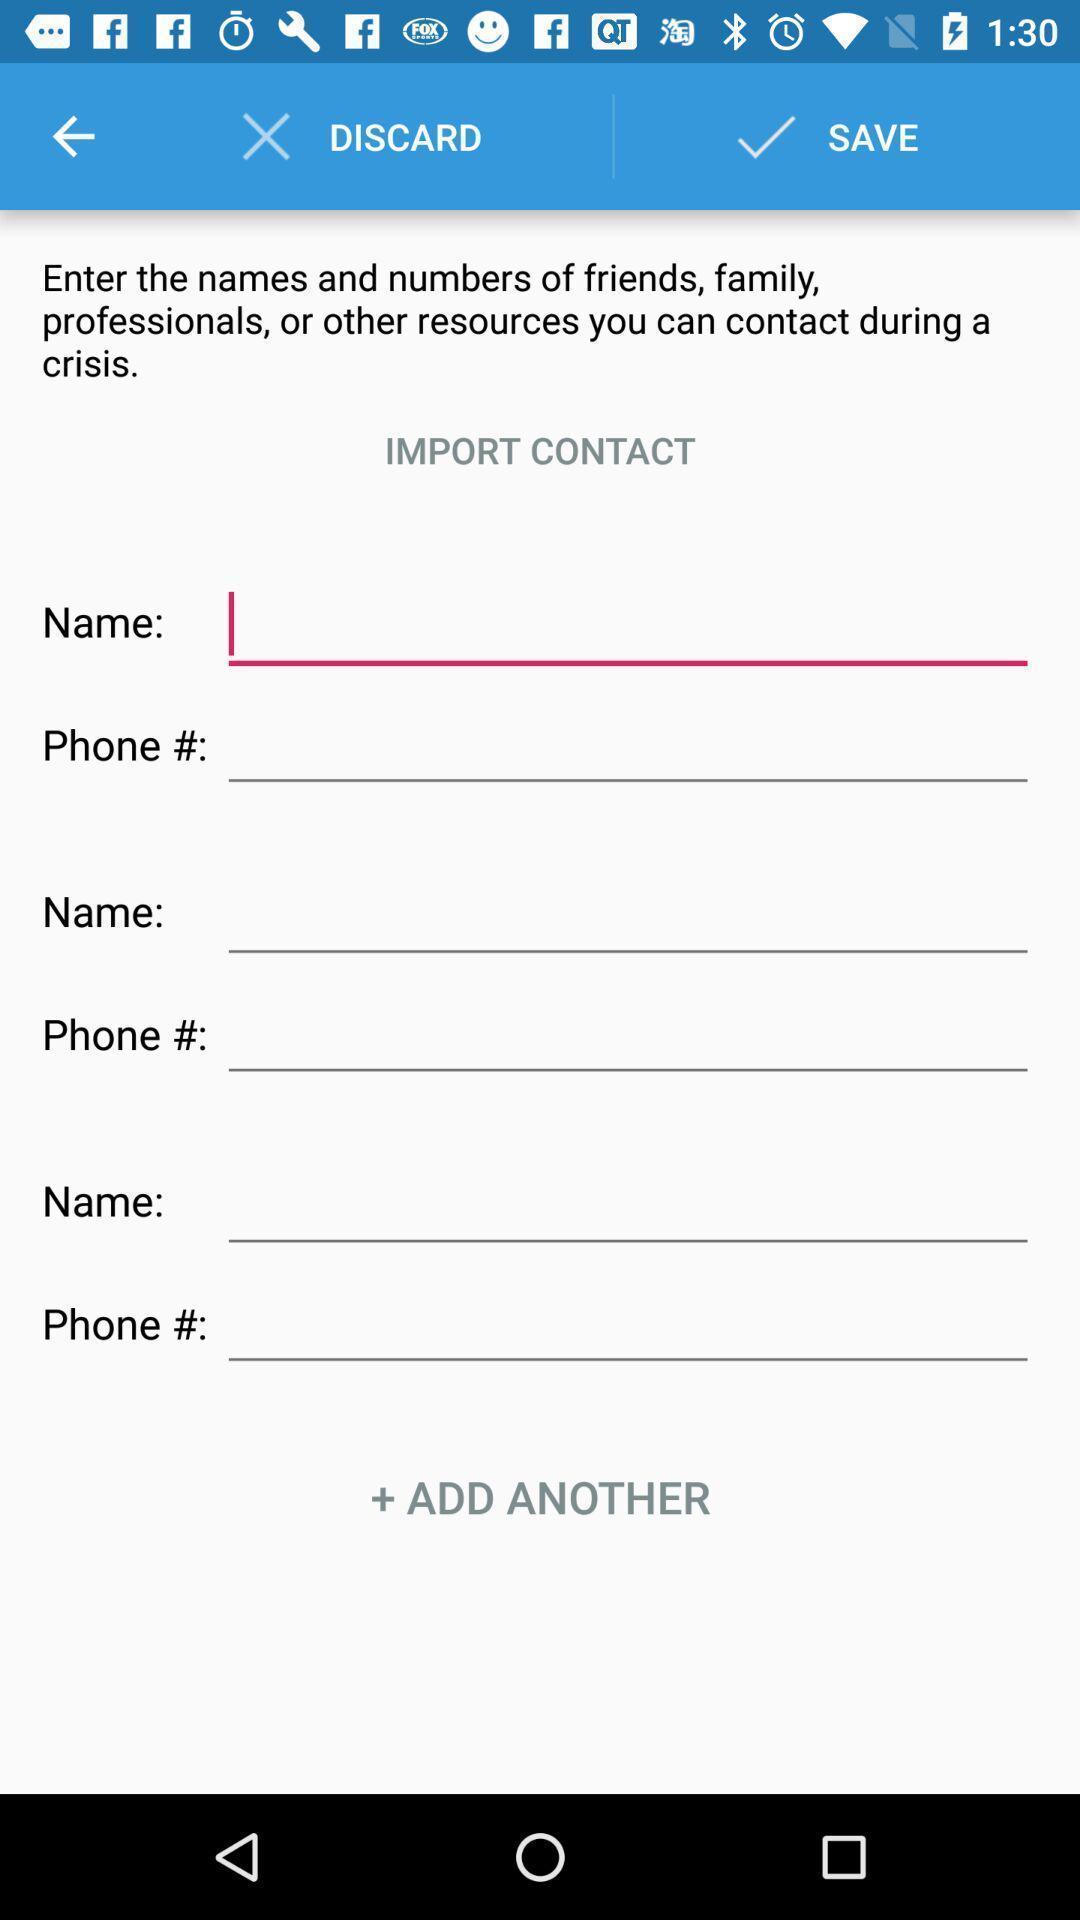Describe the content in this image. Screen displaying contents in contact page. 